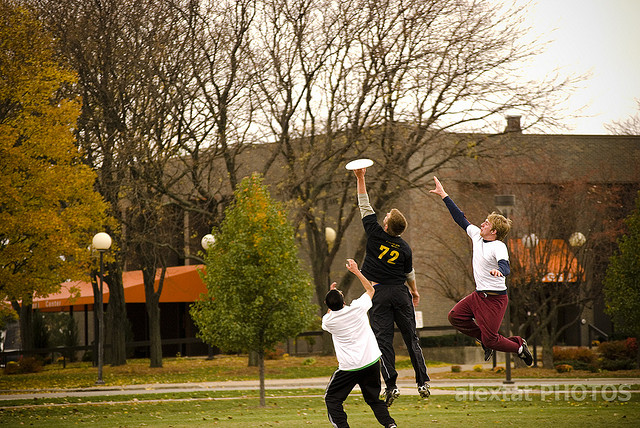What skills or qualities do these players need to demonstrate during the game?
 In the image, three young men are jumping to catch a Frisbee in mid-air. To excel in this game, the players need to demonstrate various skills and qualities such as agility, speed, coordination, and timing. They should also possess good spatial awareness to anticipate the Frisbee's trajectory and determine the best position to catch it. Besides, teamwork is crucial as players work together to effectively pass the Frisbee and score points. Communication, both verbal and non-verbal, plays a vital role in strategizing and coordinating the team's movements during the game. Overall, a combination of physical skills, mental agility, and strong teamwork fosters better performance and enjoyment in the game of Frisbee. 